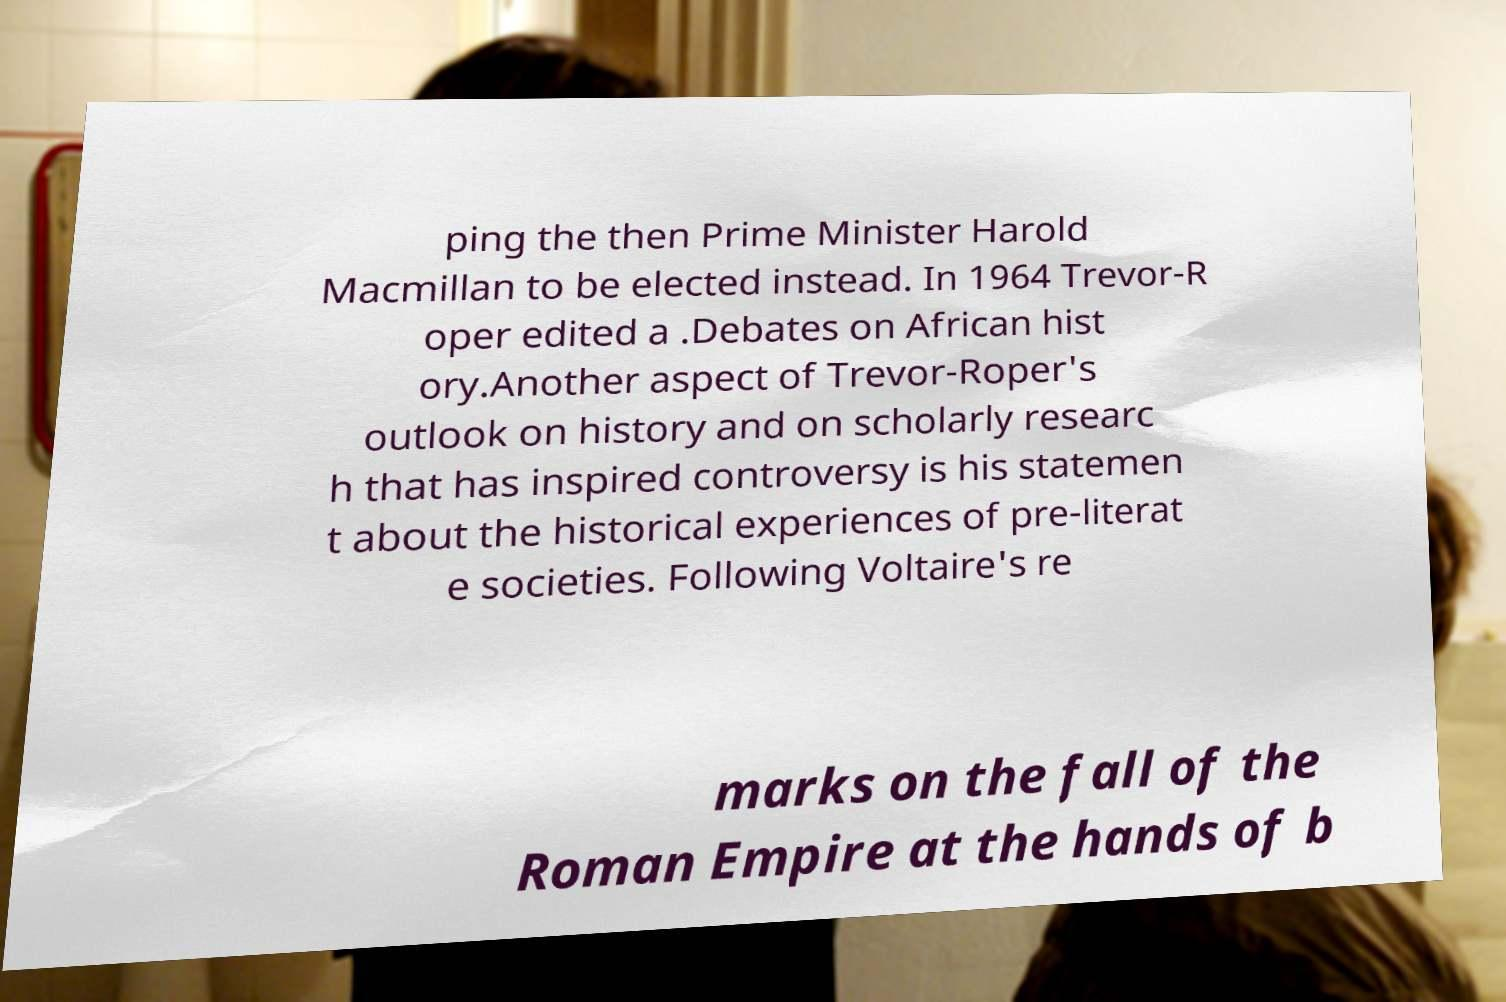There's text embedded in this image that I need extracted. Can you transcribe it verbatim? ping the then Prime Minister Harold Macmillan to be elected instead. In 1964 Trevor-R oper edited a .Debates on African hist ory.Another aspect of Trevor-Roper's outlook on history and on scholarly researc h that has inspired controversy is his statemen t about the historical experiences of pre-literat e societies. Following Voltaire's re marks on the fall of the Roman Empire at the hands of b 